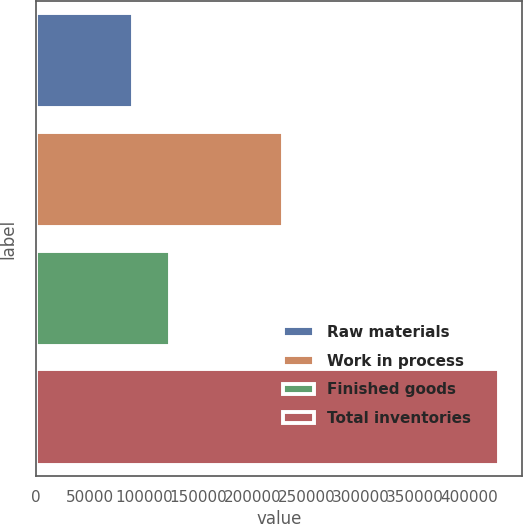Convert chart. <chart><loc_0><loc_0><loc_500><loc_500><bar_chart><fcel>Raw materials<fcel>Work in process<fcel>Finished goods<fcel>Total inventories<nl><fcel>89928<fcel>228626<fcel>123690<fcel>427551<nl></chart> 